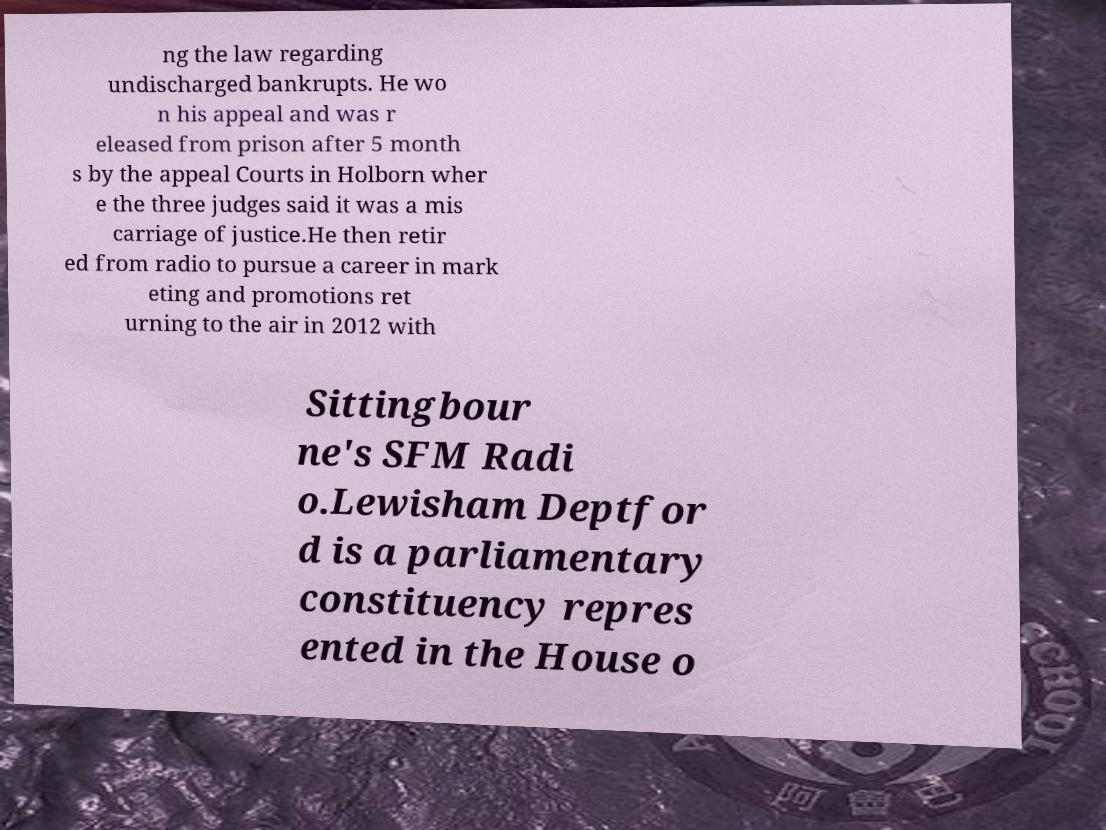I need the written content from this picture converted into text. Can you do that? ng the law regarding undischarged bankrupts. He wo n his appeal and was r eleased from prison after 5 month s by the appeal Courts in Holborn wher e the three judges said it was a mis carriage of justice.He then retir ed from radio to pursue a career in mark eting and promotions ret urning to the air in 2012 with Sittingbour ne's SFM Radi o.Lewisham Deptfor d is a parliamentary constituency repres ented in the House o 